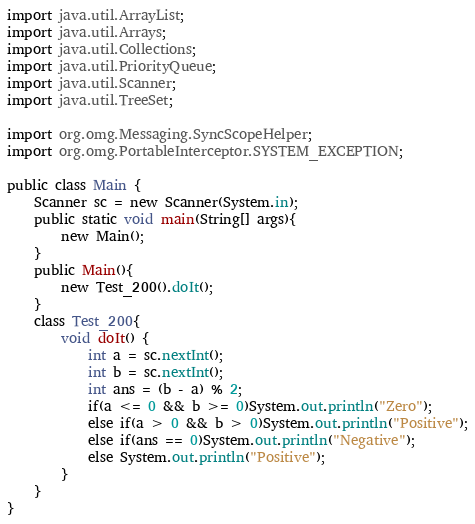<code> <loc_0><loc_0><loc_500><loc_500><_Java_>import java.util.ArrayList;
import java.util.Arrays;
import java.util.Collections;
import java.util.PriorityQueue;
import java.util.Scanner;
import java.util.TreeSet;

import org.omg.Messaging.SyncScopeHelper;
import org.omg.PortableInterceptor.SYSTEM_EXCEPTION;

public class Main {
	Scanner sc = new Scanner(System.in);
	public static void main(String[] args){
		new Main();
	}
	public Main(){
		new Test_200().doIt();
	}
	class Test_200{
		void doIt() {
			int a = sc.nextInt();
			int b = sc.nextInt();
			int ans = (b - a) % 2;
			if(a <= 0 && b >= 0)System.out.println("Zero");
			else if(a > 0 && b > 0)System.out.println("Positive");
			else if(ans == 0)System.out.println("Negative");
			else System.out.println("Positive");
		}
	}
}
</code> 